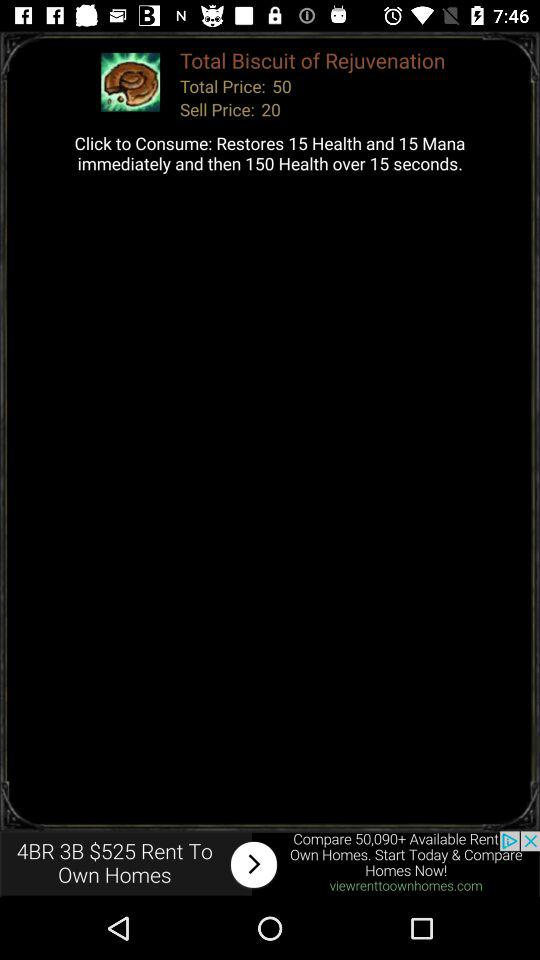What is the total price? The total price is 50. 